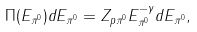Convert formula to latex. <formula><loc_0><loc_0><loc_500><loc_500>\Pi ( E _ { \pi ^ { 0 } } ) d E _ { \pi ^ { 0 } } = Z _ { p { \pi ^ { 0 } } } E _ { \pi ^ { 0 } } ^ { - \gamma } d E _ { \pi ^ { 0 } } ,</formula> 